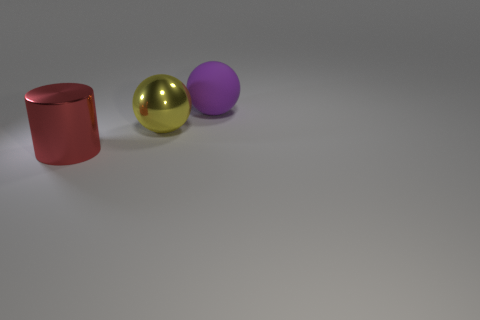Add 3 red metallic things. How many objects exist? 6 Subtract all spheres. How many objects are left? 1 Subtract all yellow metallic balls. Subtract all large shiny things. How many objects are left? 0 Add 3 matte objects. How many matte objects are left? 4 Add 1 red cylinders. How many red cylinders exist? 2 Subtract 1 red cylinders. How many objects are left? 2 